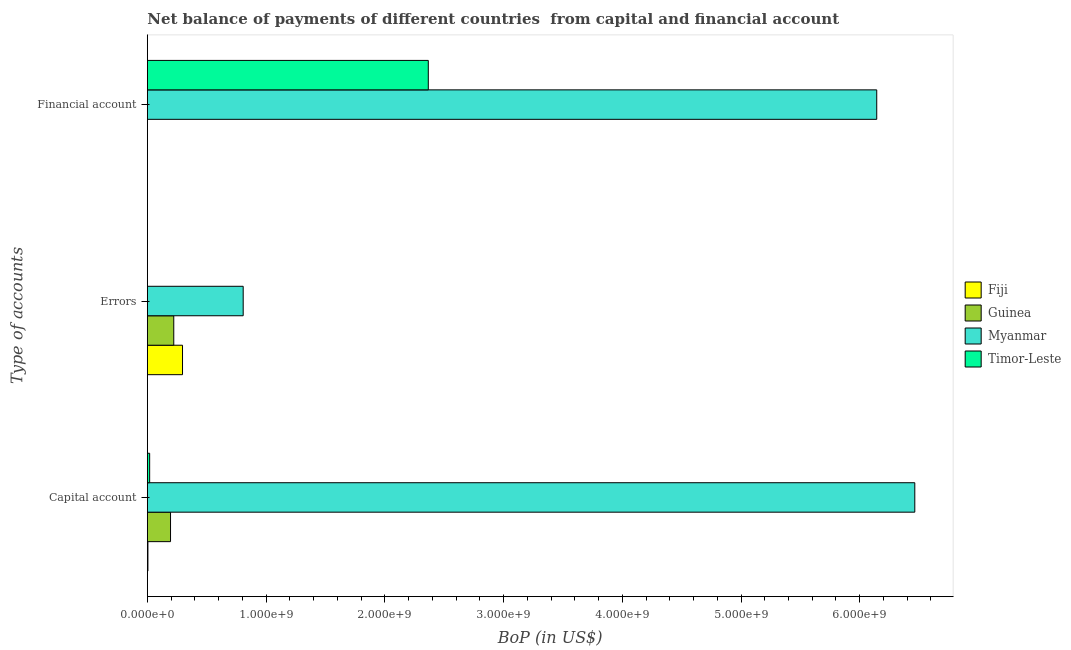Are the number of bars on each tick of the Y-axis equal?
Offer a very short reply. No. How many bars are there on the 3rd tick from the top?
Provide a succinct answer. 4. What is the label of the 3rd group of bars from the top?
Keep it short and to the point. Capital account. What is the amount of net capital account in Timor-Leste?
Your answer should be compact. 1.95e+07. Across all countries, what is the maximum amount of financial account?
Your answer should be very brief. 6.14e+09. Across all countries, what is the minimum amount of errors?
Keep it short and to the point. 0. In which country was the amount of net capital account maximum?
Your response must be concise. Myanmar. What is the total amount of errors in the graph?
Offer a very short reply. 1.33e+09. What is the difference between the amount of net capital account in Timor-Leste and that in Guinea?
Provide a succinct answer. -1.76e+08. What is the difference between the amount of net capital account in Timor-Leste and the amount of errors in Myanmar?
Offer a terse response. -7.88e+08. What is the average amount of errors per country?
Your answer should be compact. 3.31e+08. What is the difference between the amount of financial account and amount of errors in Myanmar?
Provide a succinct answer. 5.34e+09. What is the ratio of the amount of net capital account in Fiji to that in Guinea?
Your answer should be compact. 0.02. What is the difference between the highest and the second highest amount of errors?
Give a very brief answer. 5.11e+08. What is the difference between the highest and the lowest amount of financial account?
Provide a short and direct response. 6.14e+09. Is the sum of the amount of errors in Myanmar and Guinea greater than the maximum amount of net capital account across all countries?
Provide a succinct answer. No. Are all the bars in the graph horizontal?
Provide a succinct answer. Yes. How many countries are there in the graph?
Offer a terse response. 4. What is the difference between two consecutive major ticks on the X-axis?
Ensure brevity in your answer.  1.00e+09. Does the graph contain grids?
Offer a terse response. No. What is the title of the graph?
Provide a short and direct response. Net balance of payments of different countries  from capital and financial account. What is the label or title of the X-axis?
Ensure brevity in your answer.  BoP (in US$). What is the label or title of the Y-axis?
Your response must be concise. Type of accounts. What is the BoP (in US$) of Fiji in Capital account?
Your answer should be compact. 4.82e+06. What is the BoP (in US$) of Guinea in Capital account?
Provide a short and direct response. 1.95e+08. What is the BoP (in US$) of Myanmar in Capital account?
Offer a very short reply. 6.46e+09. What is the BoP (in US$) in Timor-Leste in Capital account?
Keep it short and to the point. 1.95e+07. What is the BoP (in US$) in Fiji in Errors?
Offer a terse response. 2.96e+08. What is the BoP (in US$) in Guinea in Errors?
Your response must be concise. 2.23e+08. What is the BoP (in US$) in Myanmar in Errors?
Offer a very short reply. 8.07e+08. What is the BoP (in US$) in Timor-Leste in Errors?
Your answer should be compact. 0. What is the BoP (in US$) of Fiji in Financial account?
Your answer should be compact. 0. What is the BoP (in US$) of Myanmar in Financial account?
Provide a succinct answer. 6.14e+09. What is the BoP (in US$) of Timor-Leste in Financial account?
Provide a short and direct response. 2.37e+09. Across all Type of accounts, what is the maximum BoP (in US$) in Fiji?
Make the answer very short. 2.96e+08. Across all Type of accounts, what is the maximum BoP (in US$) of Guinea?
Your answer should be very brief. 2.23e+08. Across all Type of accounts, what is the maximum BoP (in US$) in Myanmar?
Keep it short and to the point. 6.46e+09. Across all Type of accounts, what is the maximum BoP (in US$) in Timor-Leste?
Offer a very short reply. 2.37e+09. Across all Type of accounts, what is the minimum BoP (in US$) in Fiji?
Ensure brevity in your answer.  0. Across all Type of accounts, what is the minimum BoP (in US$) in Myanmar?
Give a very brief answer. 8.07e+08. What is the total BoP (in US$) of Fiji in the graph?
Provide a succinct answer. 3.01e+08. What is the total BoP (in US$) of Guinea in the graph?
Your answer should be compact. 4.18e+08. What is the total BoP (in US$) of Myanmar in the graph?
Make the answer very short. 1.34e+1. What is the total BoP (in US$) of Timor-Leste in the graph?
Give a very brief answer. 2.39e+09. What is the difference between the BoP (in US$) of Fiji in Capital account and that in Errors?
Ensure brevity in your answer.  -2.91e+08. What is the difference between the BoP (in US$) of Guinea in Capital account and that in Errors?
Provide a short and direct response. -2.73e+07. What is the difference between the BoP (in US$) in Myanmar in Capital account and that in Errors?
Offer a terse response. 5.66e+09. What is the difference between the BoP (in US$) in Myanmar in Capital account and that in Financial account?
Your response must be concise. 3.20e+08. What is the difference between the BoP (in US$) of Timor-Leste in Capital account and that in Financial account?
Your answer should be very brief. -2.35e+09. What is the difference between the BoP (in US$) of Myanmar in Errors and that in Financial account?
Offer a terse response. -5.34e+09. What is the difference between the BoP (in US$) in Fiji in Capital account and the BoP (in US$) in Guinea in Errors?
Offer a terse response. -2.18e+08. What is the difference between the BoP (in US$) of Fiji in Capital account and the BoP (in US$) of Myanmar in Errors?
Your answer should be compact. -8.02e+08. What is the difference between the BoP (in US$) of Guinea in Capital account and the BoP (in US$) of Myanmar in Errors?
Provide a short and direct response. -6.12e+08. What is the difference between the BoP (in US$) in Fiji in Capital account and the BoP (in US$) in Myanmar in Financial account?
Your answer should be compact. -6.14e+09. What is the difference between the BoP (in US$) of Fiji in Capital account and the BoP (in US$) of Timor-Leste in Financial account?
Offer a terse response. -2.36e+09. What is the difference between the BoP (in US$) of Guinea in Capital account and the BoP (in US$) of Myanmar in Financial account?
Your answer should be very brief. -5.95e+09. What is the difference between the BoP (in US$) of Guinea in Capital account and the BoP (in US$) of Timor-Leste in Financial account?
Offer a terse response. -2.17e+09. What is the difference between the BoP (in US$) of Myanmar in Capital account and the BoP (in US$) of Timor-Leste in Financial account?
Keep it short and to the point. 4.10e+09. What is the difference between the BoP (in US$) of Fiji in Errors and the BoP (in US$) of Myanmar in Financial account?
Provide a succinct answer. -5.85e+09. What is the difference between the BoP (in US$) in Fiji in Errors and the BoP (in US$) in Timor-Leste in Financial account?
Offer a terse response. -2.07e+09. What is the difference between the BoP (in US$) of Guinea in Errors and the BoP (in US$) of Myanmar in Financial account?
Give a very brief answer. -5.92e+09. What is the difference between the BoP (in US$) in Guinea in Errors and the BoP (in US$) in Timor-Leste in Financial account?
Your answer should be very brief. -2.14e+09. What is the difference between the BoP (in US$) in Myanmar in Errors and the BoP (in US$) in Timor-Leste in Financial account?
Offer a terse response. -1.56e+09. What is the average BoP (in US$) of Fiji per Type of accounts?
Make the answer very short. 1.00e+08. What is the average BoP (in US$) in Guinea per Type of accounts?
Ensure brevity in your answer.  1.39e+08. What is the average BoP (in US$) of Myanmar per Type of accounts?
Your response must be concise. 4.47e+09. What is the average BoP (in US$) of Timor-Leste per Type of accounts?
Your answer should be very brief. 7.95e+08. What is the difference between the BoP (in US$) in Fiji and BoP (in US$) in Guinea in Capital account?
Make the answer very short. -1.90e+08. What is the difference between the BoP (in US$) of Fiji and BoP (in US$) of Myanmar in Capital account?
Offer a terse response. -6.46e+09. What is the difference between the BoP (in US$) of Fiji and BoP (in US$) of Timor-Leste in Capital account?
Give a very brief answer. -1.47e+07. What is the difference between the BoP (in US$) of Guinea and BoP (in US$) of Myanmar in Capital account?
Your response must be concise. -6.27e+09. What is the difference between the BoP (in US$) in Guinea and BoP (in US$) in Timor-Leste in Capital account?
Your response must be concise. 1.76e+08. What is the difference between the BoP (in US$) of Myanmar and BoP (in US$) of Timor-Leste in Capital account?
Your answer should be very brief. 6.44e+09. What is the difference between the BoP (in US$) in Fiji and BoP (in US$) in Guinea in Errors?
Offer a very short reply. 7.36e+07. What is the difference between the BoP (in US$) of Fiji and BoP (in US$) of Myanmar in Errors?
Your response must be concise. -5.11e+08. What is the difference between the BoP (in US$) of Guinea and BoP (in US$) of Myanmar in Errors?
Make the answer very short. -5.85e+08. What is the difference between the BoP (in US$) of Myanmar and BoP (in US$) of Timor-Leste in Financial account?
Offer a terse response. 3.78e+09. What is the ratio of the BoP (in US$) in Fiji in Capital account to that in Errors?
Offer a very short reply. 0.02. What is the ratio of the BoP (in US$) in Guinea in Capital account to that in Errors?
Give a very brief answer. 0.88. What is the ratio of the BoP (in US$) in Myanmar in Capital account to that in Errors?
Your response must be concise. 8.01. What is the ratio of the BoP (in US$) of Myanmar in Capital account to that in Financial account?
Keep it short and to the point. 1.05. What is the ratio of the BoP (in US$) in Timor-Leste in Capital account to that in Financial account?
Provide a short and direct response. 0.01. What is the ratio of the BoP (in US$) in Myanmar in Errors to that in Financial account?
Provide a succinct answer. 0.13. What is the difference between the highest and the second highest BoP (in US$) in Myanmar?
Make the answer very short. 3.20e+08. What is the difference between the highest and the lowest BoP (in US$) in Fiji?
Offer a terse response. 2.96e+08. What is the difference between the highest and the lowest BoP (in US$) in Guinea?
Offer a very short reply. 2.23e+08. What is the difference between the highest and the lowest BoP (in US$) of Myanmar?
Provide a short and direct response. 5.66e+09. What is the difference between the highest and the lowest BoP (in US$) in Timor-Leste?
Provide a short and direct response. 2.37e+09. 